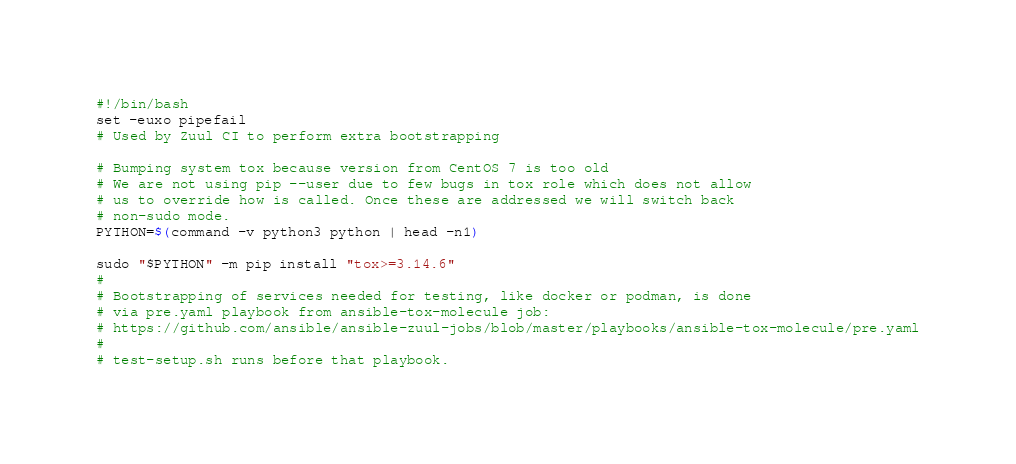Convert code to text. <code><loc_0><loc_0><loc_500><loc_500><_Bash_>#!/bin/bash
set -euxo pipefail
# Used by Zuul CI to perform extra bootstrapping

# Bumping system tox because version from CentOS 7 is too old
# We are not using pip --user due to few bugs in tox role which does not allow
# us to override how is called. Once these are addressed we will switch back
# non-sudo mode.
PYTHON=$(command -v python3 python | head -n1)

sudo "$PYTHON" -m pip install "tox>=3.14.6"
#
# Bootstrapping of services needed for testing, like docker or podman, is done
# via pre.yaml playbook from ansible-tox-molecule job:
# https://github.com/ansible/ansible-zuul-jobs/blob/master/playbooks/ansible-tox-molecule/pre.yaml
#
# test-setup.sh runs before that playbook.
</code> 